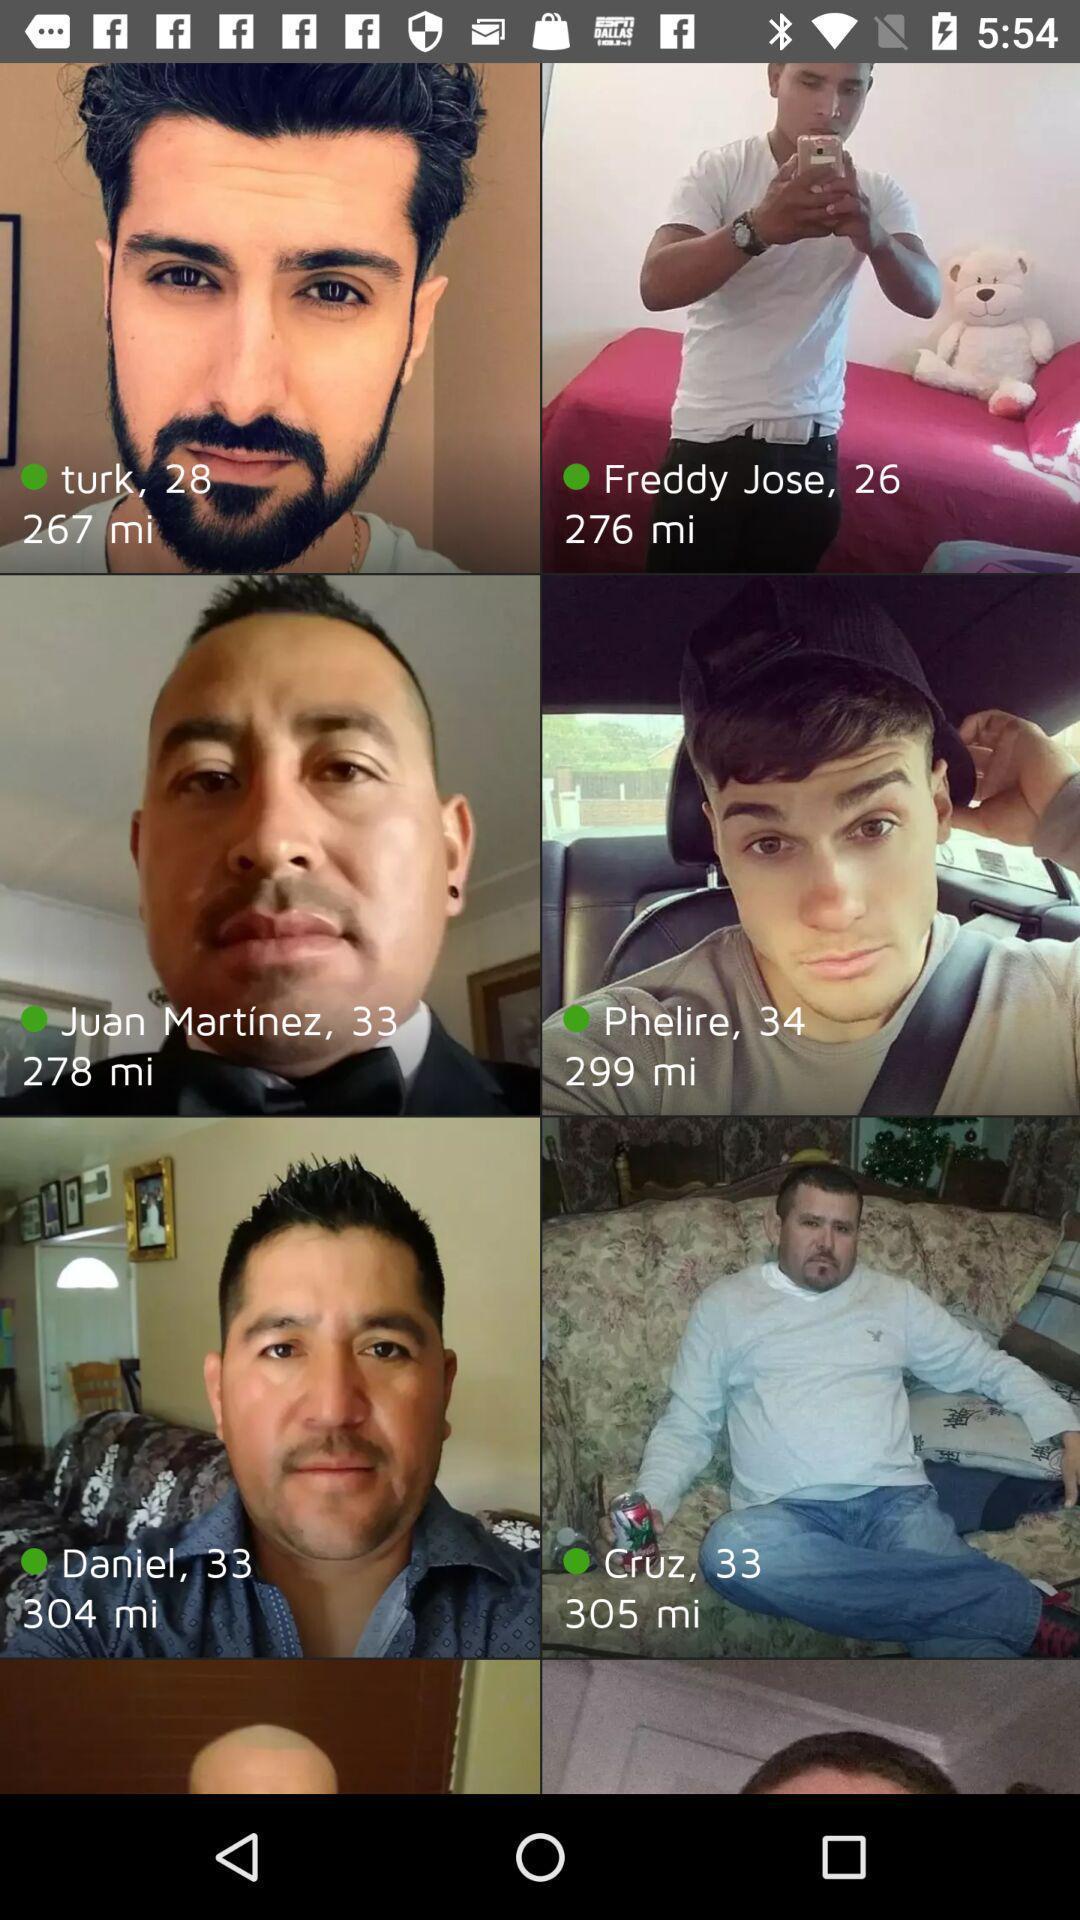Tell me what you see in this picture. Page showing different profiles on a dating app. 